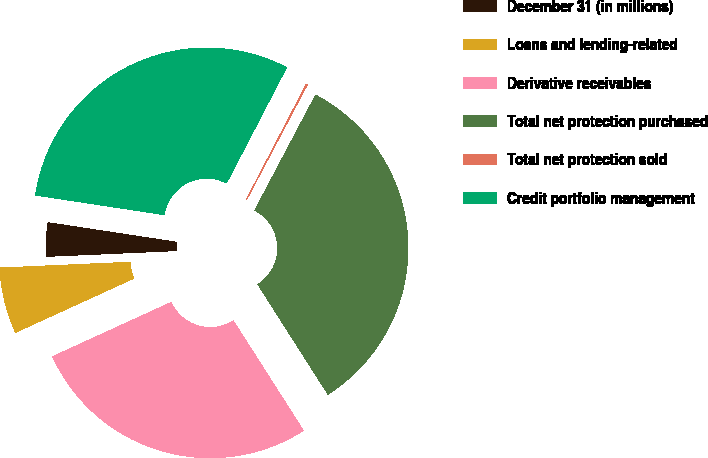Convert chart to OTSL. <chart><loc_0><loc_0><loc_500><loc_500><pie_chart><fcel>December 31 (in millions)<fcel>Loans and lending-related<fcel>Derivative receivables<fcel>Total net protection purchased<fcel>Total net protection sold<fcel>Credit portfolio management<nl><fcel>3.11%<fcel>6.12%<fcel>27.21%<fcel>33.23%<fcel>0.1%<fcel>30.22%<nl></chart> 